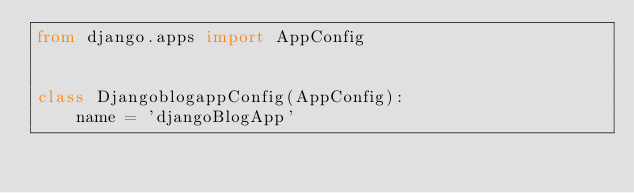Convert code to text. <code><loc_0><loc_0><loc_500><loc_500><_Python_>from django.apps import AppConfig


class DjangoblogappConfig(AppConfig):
    name = 'djangoBlogApp'
</code> 